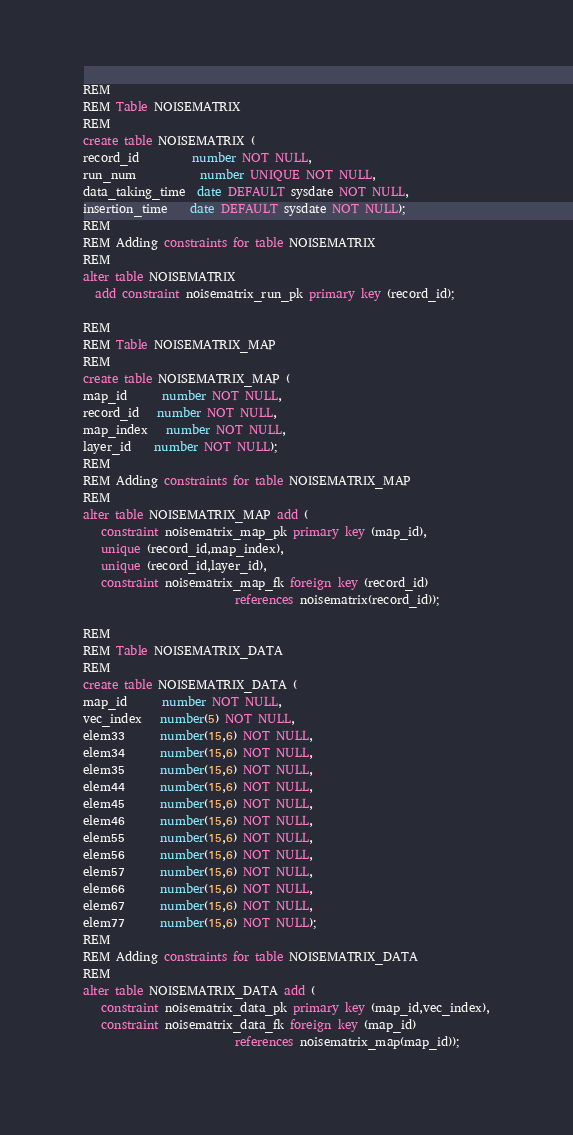<code> <loc_0><loc_0><loc_500><loc_500><_SQL_>REM
REM Table NOISEMATRIX
REM
create table NOISEMATRIX (
record_id         number NOT NULL,
run_num           number UNIQUE NOT NULL,
data_taking_time  date DEFAULT sysdate NOT NULL,
insertion_time    date DEFAULT sysdate NOT NULL);
REM
REM Adding constraints for table NOISEMATRIX
REM
alter table NOISEMATRIX
  add constraint noisematrix_run_pk primary key (record_id);

REM
REM Table NOISEMATRIX_MAP
REM
create table NOISEMATRIX_MAP (
map_id      number NOT NULL,
record_id   number NOT NULL,
map_index   number NOT NULL,
layer_id    number NOT NULL);
REM
REM Adding constraints for table NOISEMATRIX_MAP
REM
alter table NOISEMATRIX_MAP add (
   constraint noisematrix_map_pk primary key (map_id),
   unique (record_id,map_index),
   unique (record_id,layer_id),
   constraint noisematrix_map_fk foreign key (record_id)
                          references noisematrix(record_id));

REM
REM Table NOISEMATRIX_DATA
REM
create table NOISEMATRIX_DATA (
map_id      number NOT NULL,
vec_index   number(5) NOT NULL,
elem33      number(15,6) NOT NULL,
elem34      number(15,6) NOT NULL,
elem35      number(15,6) NOT NULL,
elem44      number(15,6) NOT NULL,
elem45      number(15,6) NOT NULL,
elem46      number(15,6) NOT NULL,
elem55      number(15,6) NOT NULL,
elem56      number(15,6) NOT NULL,
elem57      number(15,6) NOT NULL,
elem66      number(15,6) NOT NULL,
elem67      number(15,6) NOT NULL,
elem77      number(15,6) NOT NULL);
REM
REM Adding constraints for table NOISEMATRIX_DATA
REM
alter table NOISEMATRIX_DATA add (
   constraint noisematrix_data_pk primary key (map_id,vec_index),
   constraint noisematrix_data_fk foreign key (map_id)
                          references noisematrix_map(map_id));
</code> 